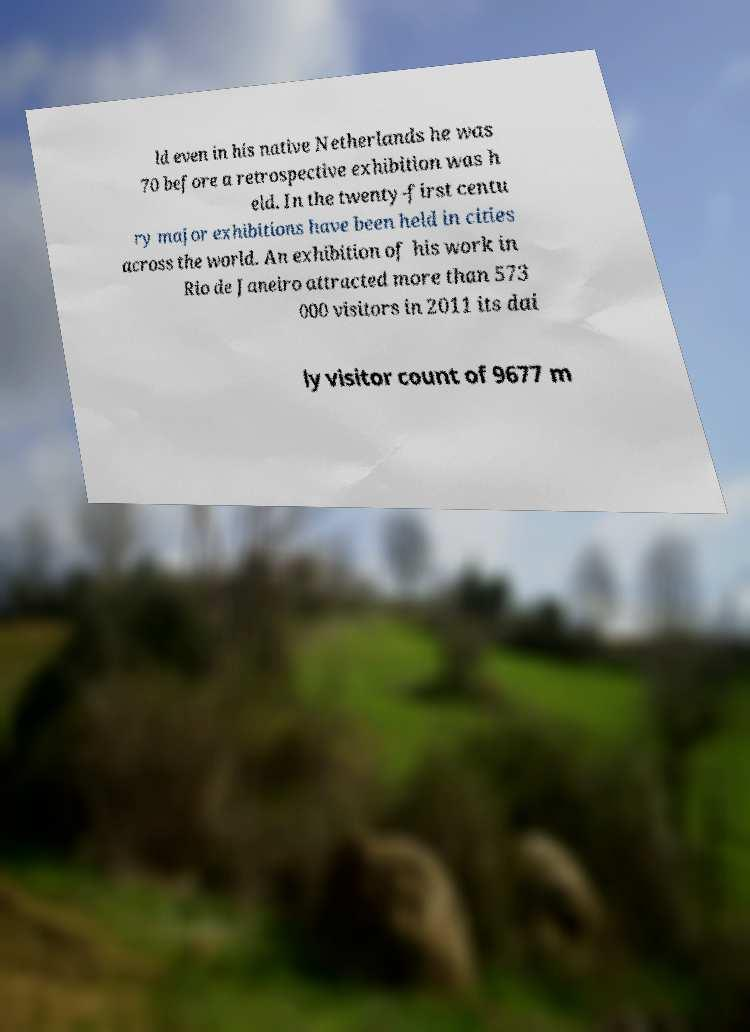Please identify and transcribe the text found in this image. ld even in his native Netherlands he was 70 before a retrospective exhibition was h eld. In the twenty-first centu ry major exhibitions have been held in cities across the world. An exhibition of his work in Rio de Janeiro attracted more than 573 000 visitors in 2011 its dai ly visitor count of 9677 m 